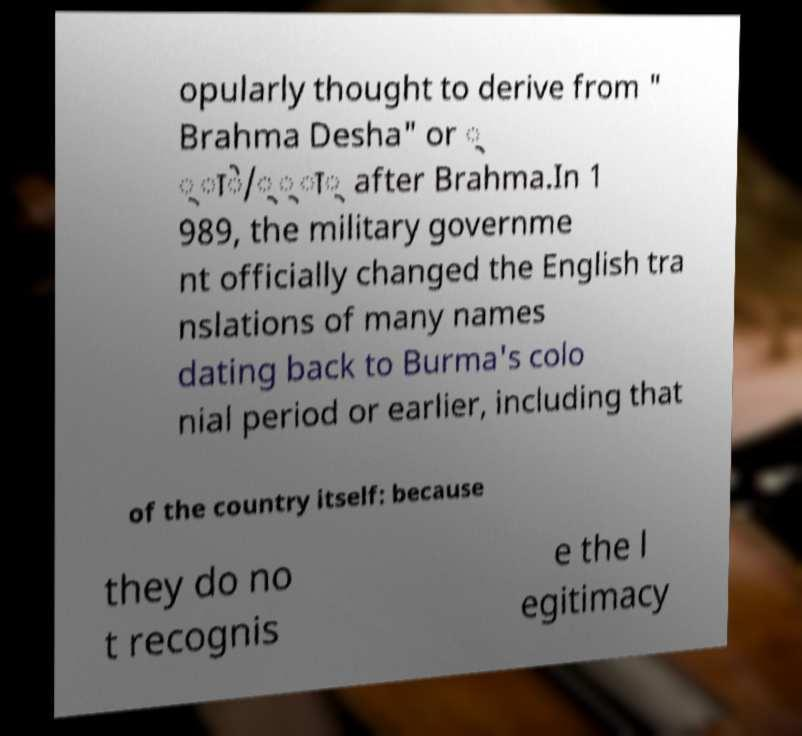For documentation purposes, I need the text within this image transcribed. Could you provide that? opularly thought to derive from " Brahma Desha" or ् ्ाे/््ा् after Brahma.In 1 989, the military governme nt officially changed the English tra nslations of many names dating back to Burma's colo nial period or earlier, including that of the country itself: because they do no t recognis e the l egitimacy 